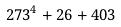Convert formula to latex. <formula><loc_0><loc_0><loc_500><loc_500>2 7 3 ^ { 4 } + 2 6 + 4 0 3</formula> 